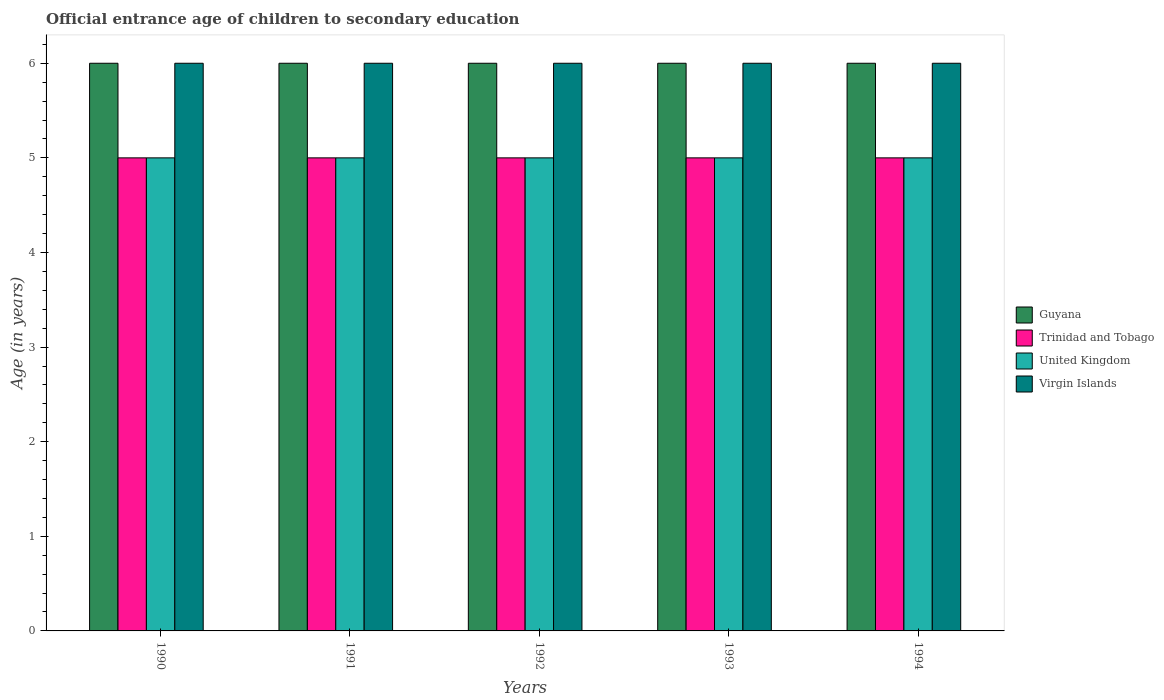How many different coloured bars are there?
Your answer should be very brief. 4. Are the number of bars per tick equal to the number of legend labels?
Offer a very short reply. Yes. How many bars are there on the 2nd tick from the left?
Your answer should be very brief. 4. How many bars are there on the 3rd tick from the right?
Your answer should be compact. 4. What is the secondary school starting age of children in Guyana in 1994?
Provide a succinct answer. 6. Across all years, what is the minimum secondary school starting age of children in Virgin Islands?
Offer a terse response. 6. What is the total secondary school starting age of children in Guyana in the graph?
Provide a succinct answer. 30. What is the difference between the secondary school starting age of children in Virgin Islands in 1990 and that in 1994?
Your answer should be compact. 0. What is the difference between the secondary school starting age of children in Guyana in 1991 and the secondary school starting age of children in United Kingdom in 1990?
Provide a short and direct response. 1. In the year 1991, what is the difference between the secondary school starting age of children in Guyana and secondary school starting age of children in Trinidad and Tobago?
Make the answer very short. 1. Is the secondary school starting age of children in Trinidad and Tobago in 1990 less than that in 1991?
Keep it short and to the point. No. Is it the case that in every year, the sum of the secondary school starting age of children in Guyana and secondary school starting age of children in Virgin Islands is greater than the sum of secondary school starting age of children in United Kingdom and secondary school starting age of children in Trinidad and Tobago?
Provide a short and direct response. Yes. What does the 1st bar from the left in 1992 represents?
Offer a terse response. Guyana. What does the 3rd bar from the right in 1994 represents?
Ensure brevity in your answer.  Trinidad and Tobago. Is it the case that in every year, the sum of the secondary school starting age of children in Trinidad and Tobago and secondary school starting age of children in Virgin Islands is greater than the secondary school starting age of children in United Kingdom?
Make the answer very short. Yes. Are all the bars in the graph horizontal?
Your response must be concise. No. How many years are there in the graph?
Offer a terse response. 5. What is the difference between two consecutive major ticks on the Y-axis?
Keep it short and to the point. 1. Does the graph contain any zero values?
Offer a very short reply. No. Does the graph contain grids?
Offer a terse response. No. Where does the legend appear in the graph?
Make the answer very short. Center right. How are the legend labels stacked?
Make the answer very short. Vertical. What is the title of the graph?
Your answer should be compact. Official entrance age of children to secondary education. Does "Nicaragua" appear as one of the legend labels in the graph?
Provide a short and direct response. No. What is the label or title of the X-axis?
Provide a short and direct response. Years. What is the label or title of the Y-axis?
Keep it short and to the point. Age (in years). What is the Age (in years) of Guyana in 1990?
Give a very brief answer. 6. What is the Age (in years) in Trinidad and Tobago in 1990?
Offer a terse response. 5. What is the Age (in years) in United Kingdom in 1990?
Offer a very short reply. 5. What is the Age (in years) in Virgin Islands in 1990?
Provide a succinct answer. 6. What is the Age (in years) of Guyana in 1991?
Your answer should be very brief. 6. What is the Age (in years) of Trinidad and Tobago in 1991?
Your answer should be very brief. 5. What is the Age (in years) of Virgin Islands in 1991?
Offer a very short reply. 6. What is the Age (in years) of Trinidad and Tobago in 1992?
Provide a succinct answer. 5. What is the Age (in years) of Guyana in 1993?
Ensure brevity in your answer.  6. What is the Age (in years) in Trinidad and Tobago in 1993?
Your response must be concise. 5. What is the Age (in years) in Guyana in 1994?
Provide a short and direct response. 6. What is the Age (in years) in Trinidad and Tobago in 1994?
Your answer should be compact. 5. What is the Age (in years) of Virgin Islands in 1994?
Your answer should be very brief. 6. Across all years, what is the maximum Age (in years) in United Kingdom?
Keep it short and to the point. 5. Across all years, what is the minimum Age (in years) in Trinidad and Tobago?
Your response must be concise. 5. Across all years, what is the minimum Age (in years) in United Kingdom?
Provide a short and direct response. 5. Across all years, what is the minimum Age (in years) in Virgin Islands?
Keep it short and to the point. 6. What is the total Age (in years) of United Kingdom in the graph?
Ensure brevity in your answer.  25. What is the total Age (in years) of Virgin Islands in the graph?
Your answer should be compact. 30. What is the difference between the Age (in years) of Guyana in 1990 and that in 1991?
Your answer should be very brief. 0. What is the difference between the Age (in years) in Virgin Islands in 1990 and that in 1991?
Give a very brief answer. 0. What is the difference between the Age (in years) of Trinidad and Tobago in 1990 and that in 1992?
Provide a short and direct response. 0. What is the difference between the Age (in years) of United Kingdom in 1990 and that in 1992?
Make the answer very short. 0. What is the difference between the Age (in years) of Guyana in 1990 and that in 1993?
Keep it short and to the point. 0. What is the difference between the Age (in years) of Trinidad and Tobago in 1990 and that in 1993?
Keep it short and to the point. 0. What is the difference between the Age (in years) of Virgin Islands in 1990 and that in 1993?
Your answer should be very brief. 0. What is the difference between the Age (in years) of Trinidad and Tobago in 1990 and that in 1994?
Provide a short and direct response. 0. What is the difference between the Age (in years) of United Kingdom in 1990 and that in 1994?
Your answer should be very brief. 0. What is the difference between the Age (in years) of Trinidad and Tobago in 1991 and that in 1992?
Offer a terse response. 0. What is the difference between the Age (in years) in United Kingdom in 1991 and that in 1992?
Offer a very short reply. 0. What is the difference between the Age (in years) of Virgin Islands in 1991 and that in 1992?
Your answer should be compact. 0. What is the difference between the Age (in years) of Trinidad and Tobago in 1991 and that in 1993?
Ensure brevity in your answer.  0. What is the difference between the Age (in years) of Virgin Islands in 1991 and that in 1993?
Your answer should be compact. 0. What is the difference between the Age (in years) of Trinidad and Tobago in 1991 and that in 1994?
Your response must be concise. 0. What is the difference between the Age (in years) of United Kingdom in 1991 and that in 1994?
Make the answer very short. 0. What is the difference between the Age (in years) of Guyana in 1992 and that in 1993?
Offer a very short reply. 0. What is the difference between the Age (in years) of Trinidad and Tobago in 1992 and that in 1993?
Make the answer very short. 0. What is the difference between the Age (in years) of Guyana in 1992 and that in 1994?
Give a very brief answer. 0. What is the difference between the Age (in years) in Trinidad and Tobago in 1992 and that in 1994?
Provide a succinct answer. 0. What is the difference between the Age (in years) in United Kingdom in 1992 and that in 1994?
Keep it short and to the point. 0. What is the difference between the Age (in years) of Virgin Islands in 1992 and that in 1994?
Provide a succinct answer. 0. What is the difference between the Age (in years) in Virgin Islands in 1993 and that in 1994?
Offer a very short reply. 0. What is the difference between the Age (in years) of Guyana in 1990 and the Age (in years) of Trinidad and Tobago in 1991?
Offer a very short reply. 1. What is the difference between the Age (in years) of Guyana in 1990 and the Age (in years) of Virgin Islands in 1991?
Your answer should be very brief. 0. What is the difference between the Age (in years) of Trinidad and Tobago in 1990 and the Age (in years) of Virgin Islands in 1991?
Provide a short and direct response. -1. What is the difference between the Age (in years) of United Kingdom in 1990 and the Age (in years) of Virgin Islands in 1991?
Provide a short and direct response. -1. What is the difference between the Age (in years) in Guyana in 1990 and the Age (in years) in Trinidad and Tobago in 1992?
Provide a succinct answer. 1. What is the difference between the Age (in years) in Guyana in 1990 and the Age (in years) in United Kingdom in 1992?
Offer a very short reply. 1. What is the difference between the Age (in years) of Guyana in 1990 and the Age (in years) of Virgin Islands in 1992?
Offer a terse response. 0. What is the difference between the Age (in years) in Trinidad and Tobago in 1990 and the Age (in years) in Virgin Islands in 1992?
Provide a succinct answer. -1. What is the difference between the Age (in years) in Guyana in 1990 and the Age (in years) in United Kingdom in 1993?
Give a very brief answer. 1. What is the difference between the Age (in years) of Guyana in 1990 and the Age (in years) of Virgin Islands in 1993?
Your response must be concise. 0. What is the difference between the Age (in years) in Guyana in 1990 and the Age (in years) in Trinidad and Tobago in 1994?
Offer a very short reply. 1. What is the difference between the Age (in years) of Guyana in 1990 and the Age (in years) of United Kingdom in 1994?
Give a very brief answer. 1. What is the difference between the Age (in years) of Guyana in 1990 and the Age (in years) of Virgin Islands in 1994?
Your answer should be compact. 0. What is the difference between the Age (in years) in Trinidad and Tobago in 1990 and the Age (in years) in United Kingdom in 1994?
Ensure brevity in your answer.  0. What is the difference between the Age (in years) in Trinidad and Tobago in 1990 and the Age (in years) in Virgin Islands in 1994?
Make the answer very short. -1. What is the difference between the Age (in years) in United Kingdom in 1990 and the Age (in years) in Virgin Islands in 1994?
Offer a terse response. -1. What is the difference between the Age (in years) of Guyana in 1991 and the Age (in years) of Trinidad and Tobago in 1992?
Provide a succinct answer. 1. What is the difference between the Age (in years) of Guyana in 1991 and the Age (in years) of Virgin Islands in 1992?
Your answer should be compact. 0. What is the difference between the Age (in years) of United Kingdom in 1991 and the Age (in years) of Virgin Islands in 1992?
Offer a very short reply. -1. What is the difference between the Age (in years) in Guyana in 1991 and the Age (in years) in United Kingdom in 1993?
Ensure brevity in your answer.  1. What is the difference between the Age (in years) in Guyana in 1991 and the Age (in years) in Virgin Islands in 1993?
Your answer should be compact. 0. What is the difference between the Age (in years) in Trinidad and Tobago in 1991 and the Age (in years) in Virgin Islands in 1993?
Offer a terse response. -1. What is the difference between the Age (in years) in United Kingdom in 1991 and the Age (in years) in Virgin Islands in 1993?
Offer a terse response. -1. What is the difference between the Age (in years) in Guyana in 1991 and the Age (in years) in United Kingdom in 1994?
Provide a short and direct response. 1. What is the difference between the Age (in years) in Trinidad and Tobago in 1991 and the Age (in years) in Virgin Islands in 1994?
Your response must be concise. -1. What is the difference between the Age (in years) of Guyana in 1992 and the Age (in years) of Virgin Islands in 1993?
Your answer should be compact. 0. What is the difference between the Age (in years) of Guyana in 1992 and the Age (in years) of Trinidad and Tobago in 1994?
Your response must be concise. 1. What is the difference between the Age (in years) in Guyana in 1992 and the Age (in years) in United Kingdom in 1994?
Offer a very short reply. 1. What is the difference between the Age (in years) of Guyana in 1992 and the Age (in years) of Virgin Islands in 1994?
Your response must be concise. 0. What is the difference between the Age (in years) in Trinidad and Tobago in 1992 and the Age (in years) in United Kingdom in 1994?
Ensure brevity in your answer.  0. What is the difference between the Age (in years) of Trinidad and Tobago in 1992 and the Age (in years) of Virgin Islands in 1994?
Give a very brief answer. -1. What is the difference between the Age (in years) in Guyana in 1993 and the Age (in years) in Trinidad and Tobago in 1994?
Keep it short and to the point. 1. What is the difference between the Age (in years) in Guyana in 1993 and the Age (in years) in United Kingdom in 1994?
Offer a terse response. 1. What is the difference between the Age (in years) in Guyana in 1993 and the Age (in years) in Virgin Islands in 1994?
Offer a very short reply. 0. What is the average Age (in years) in Guyana per year?
Your answer should be very brief. 6. What is the average Age (in years) in Trinidad and Tobago per year?
Ensure brevity in your answer.  5. What is the average Age (in years) of Virgin Islands per year?
Your answer should be very brief. 6. In the year 1990, what is the difference between the Age (in years) of Trinidad and Tobago and Age (in years) of United Kingdom?
Offer a very short reply. 0. In the year 1990, what is the difference between the Age (in years) in Trinidad and Tobago and Age (in years) in Virgin Islands?
Offer a terse response. -1. In the year 1990, what is the difference between the Age (in years) in United Kingdom and Age (in years) in Virgin Islands?
Your answer should be compact. -1. In the year 1991, what is the difference between the Age (in years) of Guyana and Age (in years) of Trinidad and Tobago?
Provide a succinct answer. 1. In the year 1991, what is the difference between the Age (in years) in Guyana and Age (in years) in Virgin Islands?
Make the answer very short. 0. In the year 1991, what is the difference between the Age (in years) of Trinidad and Tobago and Age (in years) of United Kingdom?
Your answer should be compact. 0. In the year 1992, what is the difference between the Age (in years) in Trinidad and Tobago and Age (in years) in United Kingdom?
Keep it short and to the point. 0. In the year 1992, what is the difference between the Age (in years) in Trinidad and Tobago and Age (in years) in Virgin Islands?
Keep it short and to the point. -1. In the year 1993, what is the difference between the Age (in years) of Guyana and Age (in years) of Trinidad and Tobago?
Your answer should be compact. 1. In the year 1993, what is the difference between the Age (in years) of Trinidad and Tobago and Age (in years) of United Kingdom?
Your response must be concise. 0. In the year 1994, what is the difference between the Age (in years) of Guyana and Age (in years) of Trinidad and Tobago?
Your response must be concise. 1. In the year 1994, what is the difference between the Age (in years) of Guyana and Age (in years) of United Kingdom?
Keep it short and to the point. 1. In the year 1994, what is the difference between the Age (in years) in Trinidad and Tobago and Age (in years) in Virgin Islands?
Keep it short and to the point. -1. In the year 1994, what is the difference between the Age (in years) of United Kingdom and Age (in years) of Virgin Islands?
Your answer should be very brief. -1. What is the ratio of the Age (in years) of Guyana in 1990 to that in 1991?
Your answer should be compact. 1. What is the ratio of the Age (in years) in United Kingdom in 1990 to that in 1991?
Keep it short and to the point. 1. What is the ratio of the Age (in years) of Guyana in 1990 to that in 1992?
Provide a succinct answer. 1. What is the ratio of the Age (in years) of Trinidad and Tobago in 1990 to that in 1992?
Your answer should be compact. 1. What is the ratio of the Age (in years) of United Kingdom in 1990 to that in 1992?
Your answer should be very brief. 1. What is the ratio of the Age (in years) in Virgin Islands in 1990 to that in 1992?
Your answer should be very brief. 1. What is the ratio of the Age (in years) in Guyana in 1990 to that in 1993?
Offer a terse response. 1. What is the ratio of the Age (in years) of Trinidad and Tobago in 1990 to that in 1993?
Your answer should be very brief. 1. What is the ratio of the Age (in years) of United Kingdom in 1990 to that in 1993?
Your response must be concise. 1. What is the ratio of the Age (in years) of Trinidad and Tobago in 1990 to that in 1994?
Offer a very short reply. 1. What is the ratio of the Age (in years) in Virgin Islands in 1990 to that in 1994?
Your answer should be compact. 1. What is the ratio of the Age (in years) of Trinidad and Tobago in 1991 to that in 1992?
Keep it short and to the point. 1. What is the ratio of the Age (in years) in United Kingdom in 1991 to that in 1992?
Provide a short and direct response. 1. What is the ratio of the Age (in years) of Virgin Islands in 1991 to that in 1992?
Your answer should be compact. 1. What is the ratio of the Age (in years) of Trinidad and Tobago in 1991 to that in 1993?
Give a very brief answer. 1. What is the ratio of the Age (in years) of United Kingdom in 1991 to that in 1994?
Offer a very short reply. 1. What is the ratio of the Age (in years) in Virgin Islands in 1991 to that in 1994?
Give a very brief answer. 1. What is the ratio of the Age (in years) in Guyana in 1992 to that in 1993?
Your answer should be very brief. 1. What is the ratio of the Age (in years) of Virgin Islands in 1992 to that in 1993?
Make the answer very short. 1. What is the ratio of the Age (in years) in Guyana in 1992 to that in 1994?
Your answer should be compact. 1. What is the ratio of the Age (in years) of United Kingdom in 1992 to that in 1994?
Keep it short and to the point. 1. What is the ratio of the Age (in years) of Virgin Islands in 1992 to that in 1994?
Offer a very short reply. 1. What is the ratio of the Age (in years) of Trinidad and Tobago in 1993 to that in 1994?
Make the answer very short. 1. What is the ratio of the Age (in years) in United Kingdom in 1993 to that in 1994?
Make the answer very short. 1. What is the ratio of the Age (in years) in Virgin Islands in 1993 to that in 1994?
Your response must be concise. 1. What is the difference between the highest and the second highest Age (in years) in Guyana?
Your response must be concise. 0. What is the difference between the highest and the second highest Age (in years) in United Kingdom?
Provide a succinct answer. 0. What is the difference between the highest and the lowest Age (in years) in Guyana?
Your response must be concise. 0. What is the difference between the highest and the lowest Age (in years) in United Kingdom?
Keep it short and to the point. 0. What is the difference between the highest and the lowest Age (in years) in Virgin Islands?
Ensure brevity in your answer.  0. 